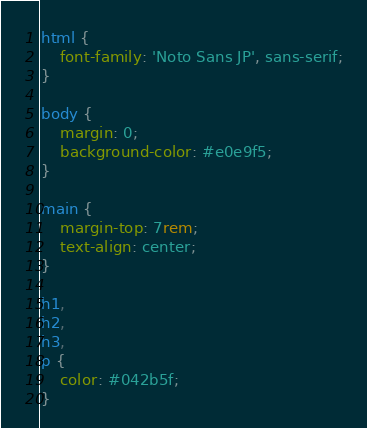<code> <loc_0><loc_0><loc_500><loc_500><_CSS_>
html {
    font-family: 'Noto Sans JP', sans-serif;
}

body {
    margin: 0;
    background-color: #e0e9f5;
}

main {
    margin-top: 7rem;
    text-align: center;
}

h1,
h2,
h3,
p {
    color: #042b5f;
}</code> 